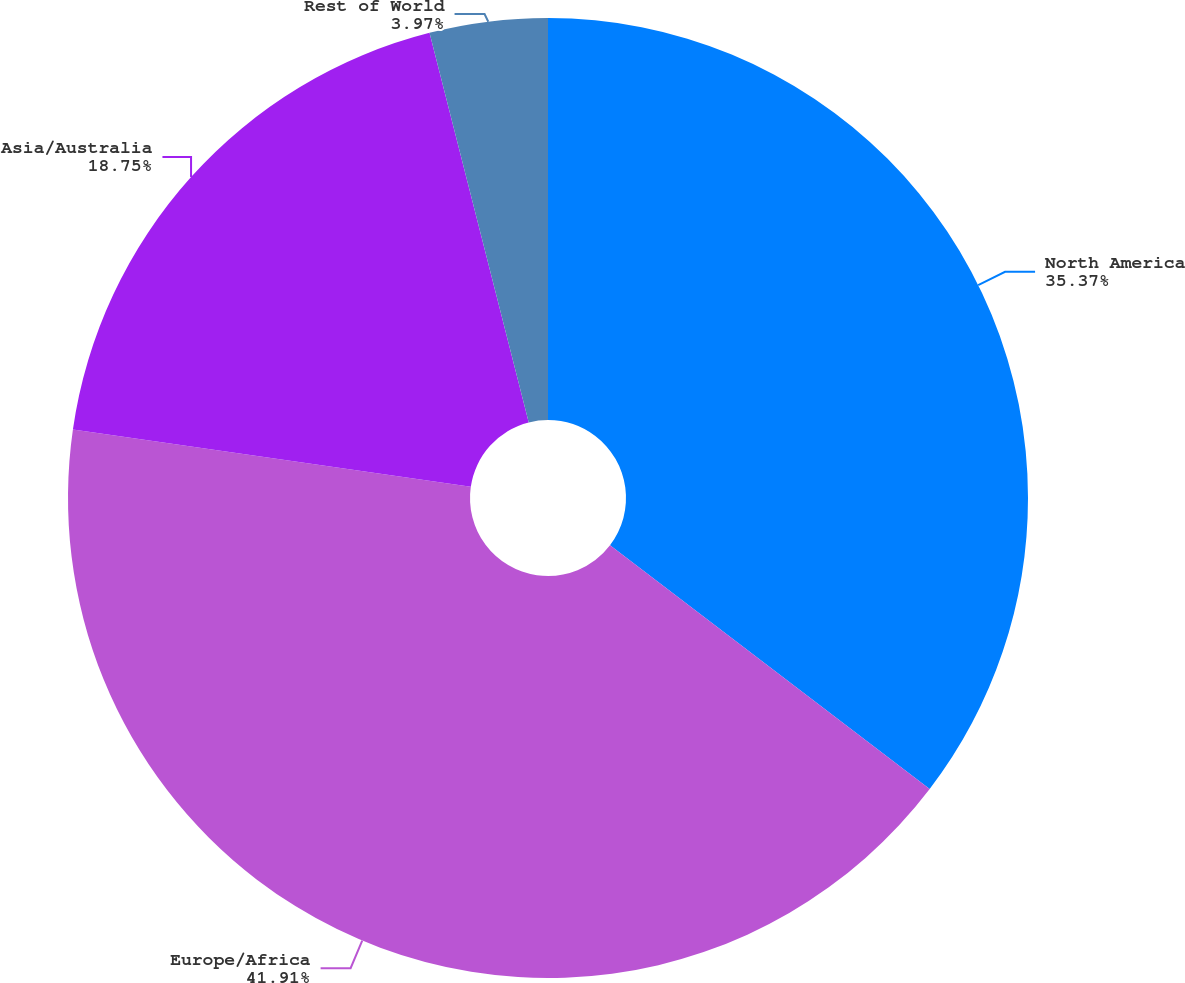<chart> <loc_0><loc_0><loc_500><loc_500><pie_chart><fcel>North America<fcel>Europe/Africa<fcel>Asia/Australia<fcel>Rest of World<nl><fcel>35.37%<fcel>41.91%<fcel>18.75%<fcel>3.97%<nl></chart> 